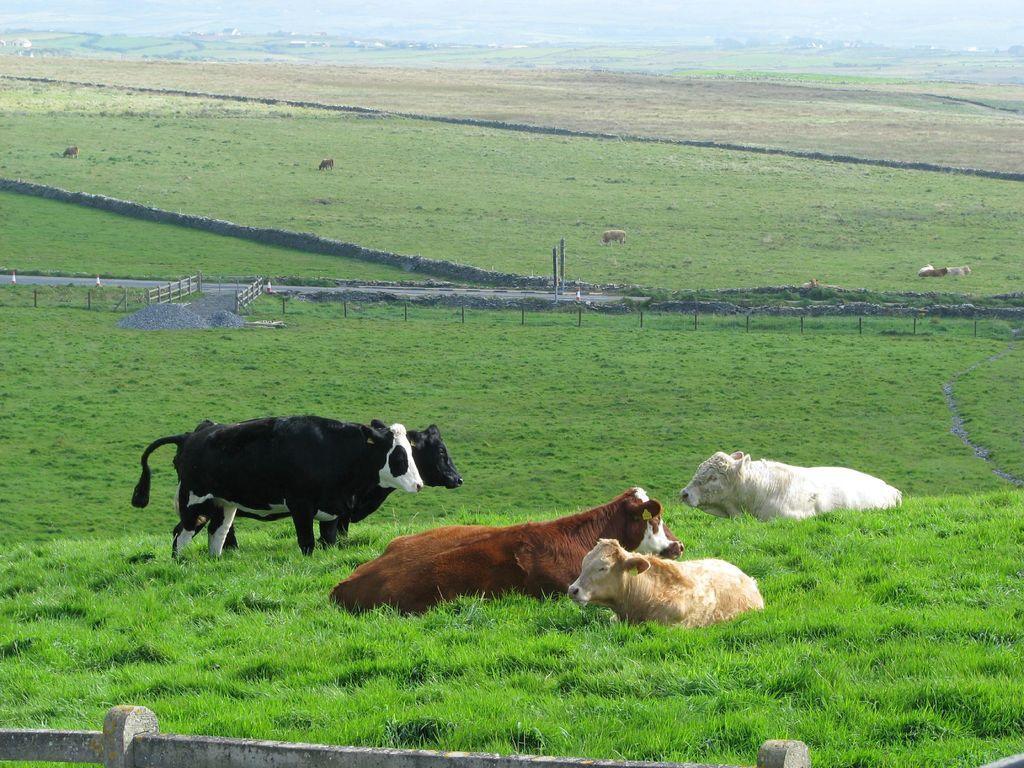Can you describe this image briefly? In this picture I can see animals on the surface. I can see the metal grill fence. I can see the farm fields. I can see green grass. 